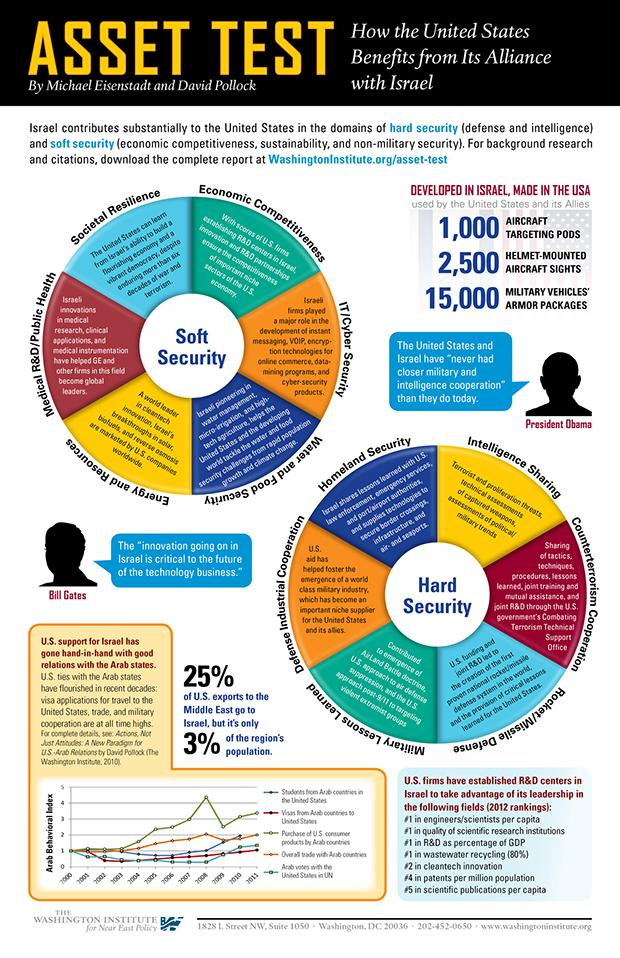Give some essential details in this illustration. In 2008, the overall trade with Arab countries reached its highest level. The United States takes advantage of Israel in seven different fields. Hard Security is divided into six parts. In 2008, the purchase of consumer products from America by Arab countries reached its highest level. A majority of U.S. exports to the Middle East do not go to Israel, which is approximately 75%. 